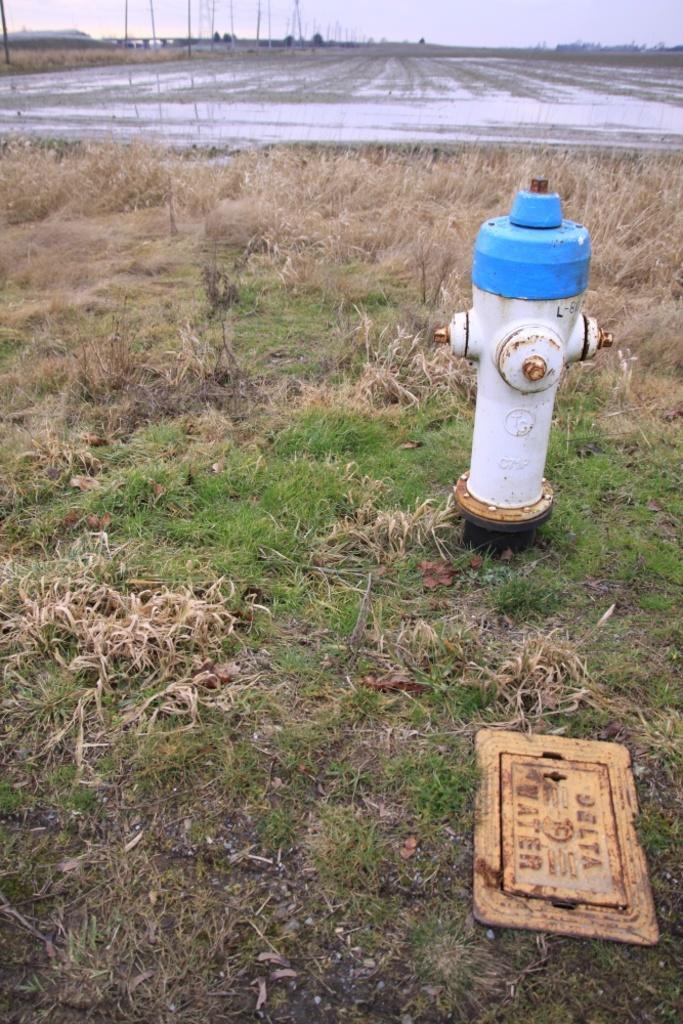Can you describe this image briefly? In the picture I can see a fire hydrant, the grass and a board which has something written on it. In the background I can see poles and the sky. 